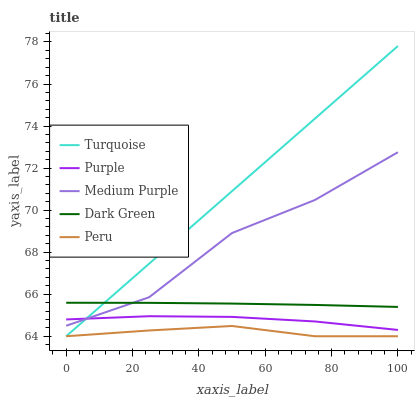Does Peru have the minimum area under the curve?
Answer yes or no. Yes. Does Turquoise have the maximum area under the curve?
Answer yes or no. Yes. Does Medium Purple have the minimum area under the curve?
Answer yes or no. No. Does Medium Purple have the maximum area under the curve?
Answer yes or no. No. Is Turquoise the smoothest?
Answer yes or no. Yes. Is Medium Purple the roughest?
Answer yes or no. Yes. Is Medium Purple the smoothest?
Answer yes or no. No. Is Turquoise the roughest?
Answer yes or no. No. Does Turquoise have the lowest value?
Answer yes or no. Yes. Does Medium Purple have the lowest value?
Answer yes or no. No. Does Turquoise have the highest value?
Answer yes or no. Yes. Does Medium Purple have the highest value?
Answer yes or no. No. Is Peru less than Purple?
Answer yes or no. Yes. Is Dark Green greater than Purple?
Answer yes or no. Yes. Does Purple intersect Turquoise?
Answer yes or no. Yes. Is Purple less than Turquoise?
Answer yes or no. No. Is Purple greater than Turquoise?
Answer yes or no. No. Does Peru intersect Purple?
Answer yes or no. No. 